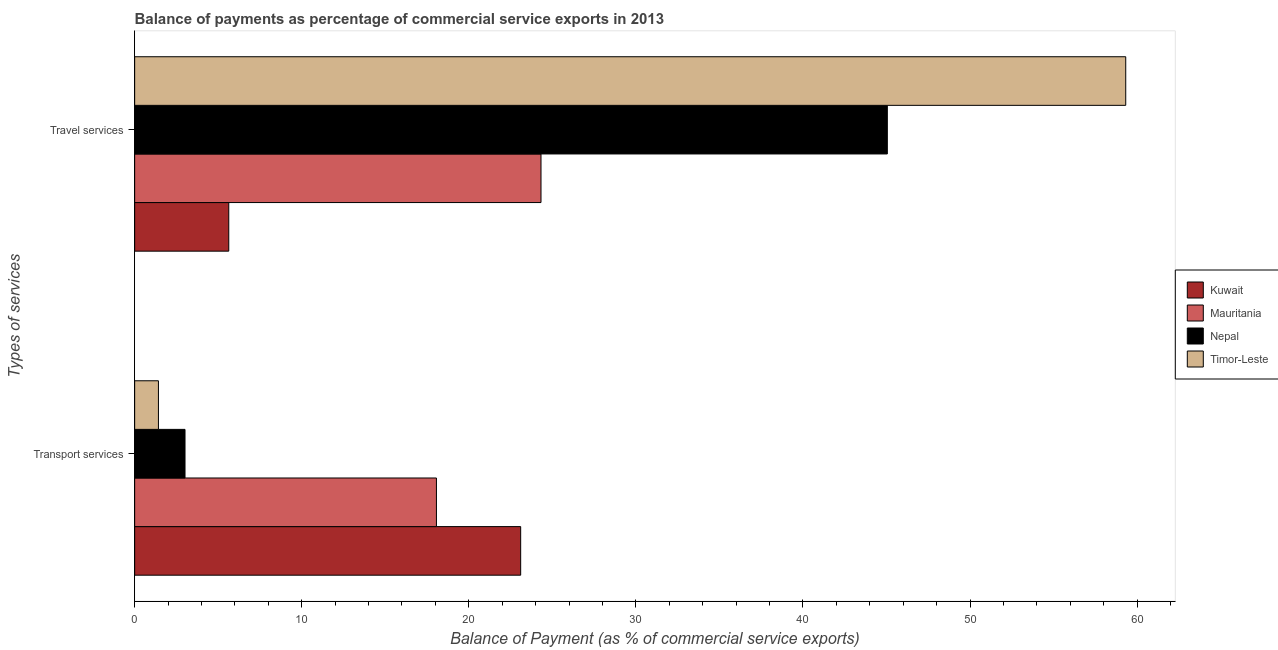How many groups of bars are there?
Your response must be concise. 2. Are the number of bars on each tick of the Y-axis equal?
Provide a succinct answer. Yes. How many bars are there on the 1st tick from the top?
Your answer should be very brief. 4. How many bars are there on the 2nd tick from the bottom?
Offer a very short reply. 4. What is the label of the 2nd group of bars from the top?
Ensure brevity in your answer.  Transport services. What is the balance of payments of travel services in Timor-Leste?
Make the answer very short. 59.32. Across all countries, what is the maximum balance of payments of transport services?
Keep it short and to the point. 23.1. Across all countries, what is the minimum balance of payments of travel services?
Your answer should be compact. 5.63. In which country was the balance of payments of transport services maximum?
Your answer should be compact. Kuwait. In which country was the balance of payments of travel services minimum?
Your response must be concise. Kuwait. What is the total balance of payments of travel services in the graph?
Your answer should be very brief. 134.32. What is the difference between the balance of payments of transport services in Kuwait and that in Nepal?
Make the answer very short. 20.09. What is the difference between the balance of payments of travel services in Nepal and the balance of payments of transport services in Timor-Leste?
Provide a short and direct response. 43.63. What is the average balance of payments of transport services per country?
Your response must be concise. 11.4. What is the difference between the balance of payments of travel services and balance of payments of transport services in Timor-Leste?
Keep it short and to the point. 57.9. What is the ratio of the balance of payments of travel services in Mauritania to that in Nepal?
Ensure brevity in your answer.  0.54. What does the 3rd bar from the top in Transport services represents?
Give a very brief answer. Mauritania. What does the 4th bar from the bottom in Travel services represents?
Offer a terse response. Timor-Leste. How many bars are there?
Your answer should be very brief. 8. Are all the bars in the graph horizontal?
Make the answer very short. Yes. How many countries are there in the graph?
Offer a terse response. 4. Are the values on the major ticks of X-axis written in scientific E-notation?
Your answer should be very brief. No. Does the graph contain any zero values?
Make the answer very short. No. Where does the legend appear in the graph?
Give a very brief answer. Center right. How many legend labels are there?
Keep it short and to the point. 4. What is the title of the graph?
Provide a short and direct response. Balance of payments as percentage of commercial service exports in 2013. Does "Lesotho" appear as one of the legend labels in the graph?
Offer a terse response. No. What is the label or title of the X-axis?
Offer a very short reply. Balance of Payment (as % of commercial service exports). What is the label or title of the Y-axis?
Provide a succinct answer. Types of services. What is the Balance of Payment (as % of commercial service exports) of Kuwait in Transport services?
Offer a terse response. 23.1. What is the Balance of Payment (as % of commercial service exports) of Mauritania in Transport services?
Provide a succinct answer. 18.06. What is the Balance of Payment (as % of commercial service exports) in Nepal in Transport services?
Provide a succinct answer. 3.01. What is the Balance of Payment (as % of commercial service exports) of Timor-Leste in Transport services?
Give a very brief answer. 1.42. What is the Balance of Payment (as % of commercial service exports) of Kuwait in Travel services?
Offer a very short reply. 5.63. What is the Balance of Payment (as % of commercial service exports) in Mauritania in Travel services?
Your answer should be compact. 24.32. What is the Balance of Payment (as % of commercial service exports) in Nepal in Travel services?
Your answer should be compact. 45.05. What is the Balance of Payment (as % of commercial service exports) of Timor-Leste in Travel services?
Ensure brevity in your answer.  59.32. Across all Types of services, what is the maximum Balance of Payment (as % of commercial service exports) in Kuwait?
Keep it short and to the point. 23.1. Across all Types of services, what is the maximum Balance of Payment (as % of commercial service exports) of Mauritania?
Keep it short and to the point. 24.32. Across all Types of services, what is the maximum Balance of Payment (as % of commercial service exports) in Nepal?
Your answer should be compact. 45.05. Across all Types of services, what is the maximum Balance of Payment (as % of commercial service exports) in Timor-Leste?
Keep it short and to the point. 59.32. Across all Types of services, what is the minimum Balance of Payment (as % of commercial service exports) in Kuwait?
Provide a short and direct response. 5.63. Across all Types of services, what is the minimum Balance of Payment (as % of commercial service exports) of Mauritania?
Provide a succinct answer. 18.06. Across all Types of services, what is the minimum Balance of Payment (as % of commercial service exports) in Nepal?
Keep it short and to the point. 3.01. Across all Types of services, what is the minimum Balance of Payment (as % of commercial service exports) of Timor-Leste?
Your answer should be very brief. 1.42. What is the total Balance of Payment (as % of commercial service exports) of Kuwait in the graph?
Your answer should be very brief. 28.74. What is the total Balance of Payment (as % of commercial service exports) of Mauritania in the graph?
Offer a terse response. 42.38. What is the total Balance of Payment (as % of commercial service exports) of Nepal in the graph?
Give a very brief answer. 48.06. What is the total Balance of Payment (as % of commercial service exports) in Timor-Leste in the graph?
Offer a very short reply. 60.74. What is the difference between the Balance of Payment (as % of commercial service exports) of Kuwait in Transport services and that in Travel services?
Your answer should be compact. 17.47. What is the difference between the Balance of Payment (as % of commercial service exports) of Mauritania in Transport services and that in Travel services?
Your answer should be compact. -6.26. What is the difference between the Balance of Payment (as % of commercial service exports) of Nepal in Transport services and that in Travel services?
Keep it short and to the point. -42.04. What is the difference between the Balance of Payment (as % of commercial service exports) of Timor-Leste in Transport services and that in Travel services?
Your answer should be very brief. -57.9. What is the difference between the Balance of Payment (as % of commercial service exports) in Kuwait in Transport services and the Balance of Payment (as % of commercial service exports) in Mauritania in Travel services?
Your response must be concise. -1.22. What is the difference between the Balance of Payment (as % of commercial service exports) in Kuwait in Transport services and the Balance of Payment (as % of commercial service exports) in Nepal in Travel services?
Offer a very short reply. -21.95. What is the difference between the Balance of Payment (as % of commercial service exports) of Kuwait in Transport services and the Balance of Payment (as % of commercial service exports) of Timor-Leste in Travel services?
Offer a very short reply. -36.22. What is the difference between the Balance of Payment (as % of commercial service exports) of Mauritania in Transport services and the Balance of Payment (as % of commercial service exports) of Nepal in Travel services?
Give a very brief answer. -26.99. What is the difference between the Balance of Payment (as % of commercial service exports) in Mauritania in Transport services and the Balance of Payment (as % of commercial service exports) in Timor-Leste in Travel services?
Ensure brevity in your answer.  -41.26. What is the difference between the Balance of Payment (as % of commercial service exports) of Nepal in Transport services and the Balance of Payment (as % of commercial service exports) of Timor-Leste in Travel services?
Keep it short and to the point. -56.31. What is the average Balance of Payment (as % of commercial service exports) of Kuwait per Types of services?
Your answer should be compact. 14.37. What is the average Balance of Payment (as % of commercial service exports) in Mauritania per Types of services?
Provide a short and direct response. 21.19. What is the average Balance of Payment (as % of commercial service exports) of Nepal per Types of services?
Provide a short and direct response. 24.03. What is the average Balance of Payment (as % of commercial service exports) of Timor-Leste per Types of services?
Keep it short and to the point. 30.37. What is the difference between the Balance of Payment (as % of commercial service exports) in Kuwait and Balance of Payment (as % of commercial service exports) in Mauritania in Transport services?
Give a very brief answer. 5.04. What is the difference between the Balance of Payment (as % of commercial service exports) in Kuwait and Balance of Payment (as % of commercial service exports) in Nepal in Transport services?
Ensure brevity in your answer.  20.09. What is the difference between the Balance of Payment (as % of commercial service exports) in Kuwait and Balance of Payment (as % of commercial service exports) in Timor-Leste in Transport services?
Your answer should be very brief. 21.68. What is the difference between the Balance of Payment (as % of commercial service exports) of Mauritania and Balance of Payment (as % of commercial service exports) of Nepal in Transport services?
Keep it short and to the point. 15.05. What is the difference between the Balance of Payment (as % of commercial service exports) of Mauritania and Balance of Payment (as % of commercial service exports) of Timor-Leste in Transport services?
Ensure brevity in your answer.  16.64. What is the difference between the Balance of Payment (as % of commercial service exports) in Nepal and Balance of Payment (as % of commercial service exports) in Timor-Leste in Transport services?
Keep it short and to the point. 1.59. What is the difference between the Balance of Payment (as % of commercial service exports) in Kuwait and Balance of Payment (as % of commercial service exports) in Mauritania in Travel services?
Provide a short and direct response. -18.69. What is the difference between the Balance of Payment (as % of commercial service exports) of Kuwait and Balance of Payment (as % of commercial service exports) of Nepal in Travel services?
Your answer should be very brief. -39.42. What is the difference between the Balance of Payment (as % of commercial service exports) of Kuwait and Balance of Payment (as % of commercial service exports) of Timor-Leste in Travel services?
Offer a very short reply. -53.69. What is the difference between the Balance of Payment (as % of commercial service exports) in Mauritania and Balance of Payment (as % of commercial service exports) in Nepal in Travel services?
Offer a terse response. -20.73. What is the difference between the Balance of Payment (as % of commercial service exports) of Mauritania and Balance of Payment (as % of commercial service exports) of Timor-Leste in Travel services?
Your answer should be compact. -35. What is the difference between the Balance of Payment (as % of commercial service exports) in Nepal and Balance of Payment (as % of commercial service exports) in Timor-Leste in Travel services?
Ensure brevity in your answer.  -14.27. What is the ratio of the Balance of Payment (as % of commercial service exports) of Kuwait in Transport services to that in Travel services?
Your response must be concise. 4.1. What is the ratio of the Balance of Payment (as % of commercial service exports) in Mauritania in Transport services to that in Travel services?
Offer a terse response. 0.74. What is the ratio of the Balance of Payment (as % of commercial service exports) in Nepal in Transport services to that in Travel services?
Keep it short and to the point. 0.07. What is the ratio of the Balance of Payment (as % of commercial service exports) of Timor-Leste in Transport services to that in Travel services?
Your answer should be compact. 0.02. What is the difference between the highest and the second highest Balance of Payment (as % of commercial service exports) in Kuwait?
Ensure brevity in your answer.  17.47. What is the difference between the highest and the second highest Balance of Payment (as % of commercial service exports) of Mauritania?
Your answer should be very brief. 6.26. What is the difference between the highest and the second highest Balance of Payment (as % of commercial service exports) in Nepal?
Your answer should be very brief. 42.04. What is the difference between the highest and the second highest Balance of Payment (as % of commercial service exports) of Timor-Leste?
Provide a short and direct response. 57.9. What is the difference between the highest and the lowest Balance of Payment (as % of commercial service exports) in Kuwait?
Your answer should be very brief. 17.47. What is the difference between the highest and the lowest Balance of Payment (as % of commercial service exports) of Mauritania?
Make the answer very short. 6.26. What is the difference between the highest and the lowest Balance of Payment (as % of commercial service exports) in Nepal?
Provide a succinct answer. 42.04. What is the difference between the highest and the lowest Balance of Payment (as % of commercial service exports) in Timor-Leste?
Give a very brief answer. 57.9. 